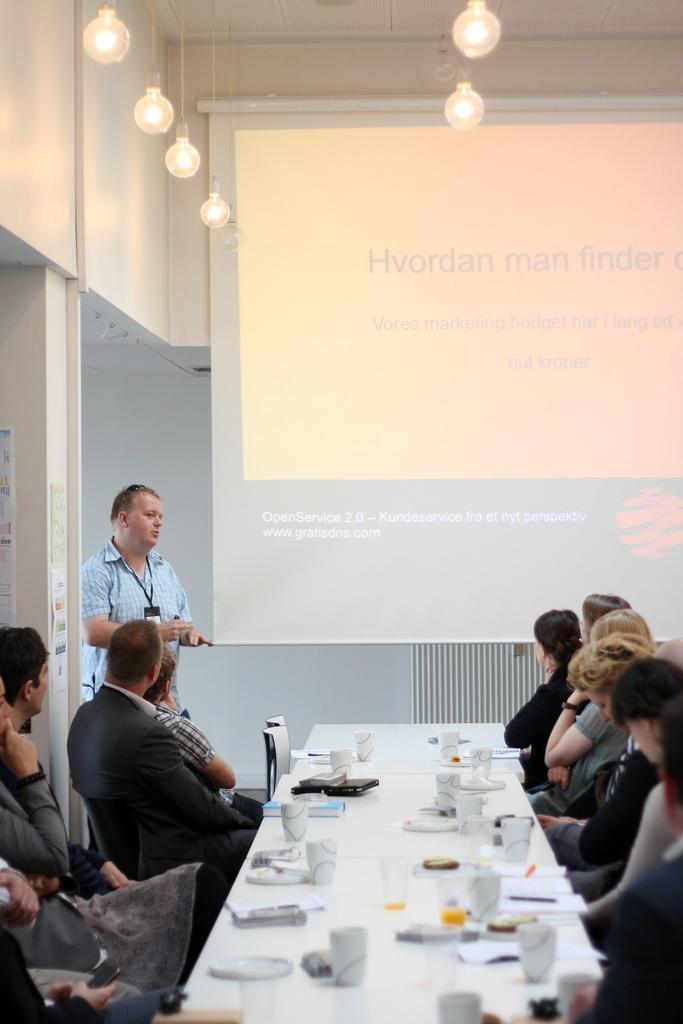Please provide a concise description of this image. The picture is taken inside a room and there are few people in the room. People are seated on chairs at the table and looking at the board. There are cups and books on the table. On the projector board some text is displayed. the man standing is addressing the crowd and he is wearing a tag. There are bulbs hanged to the ceiling. In the background there is wall. 